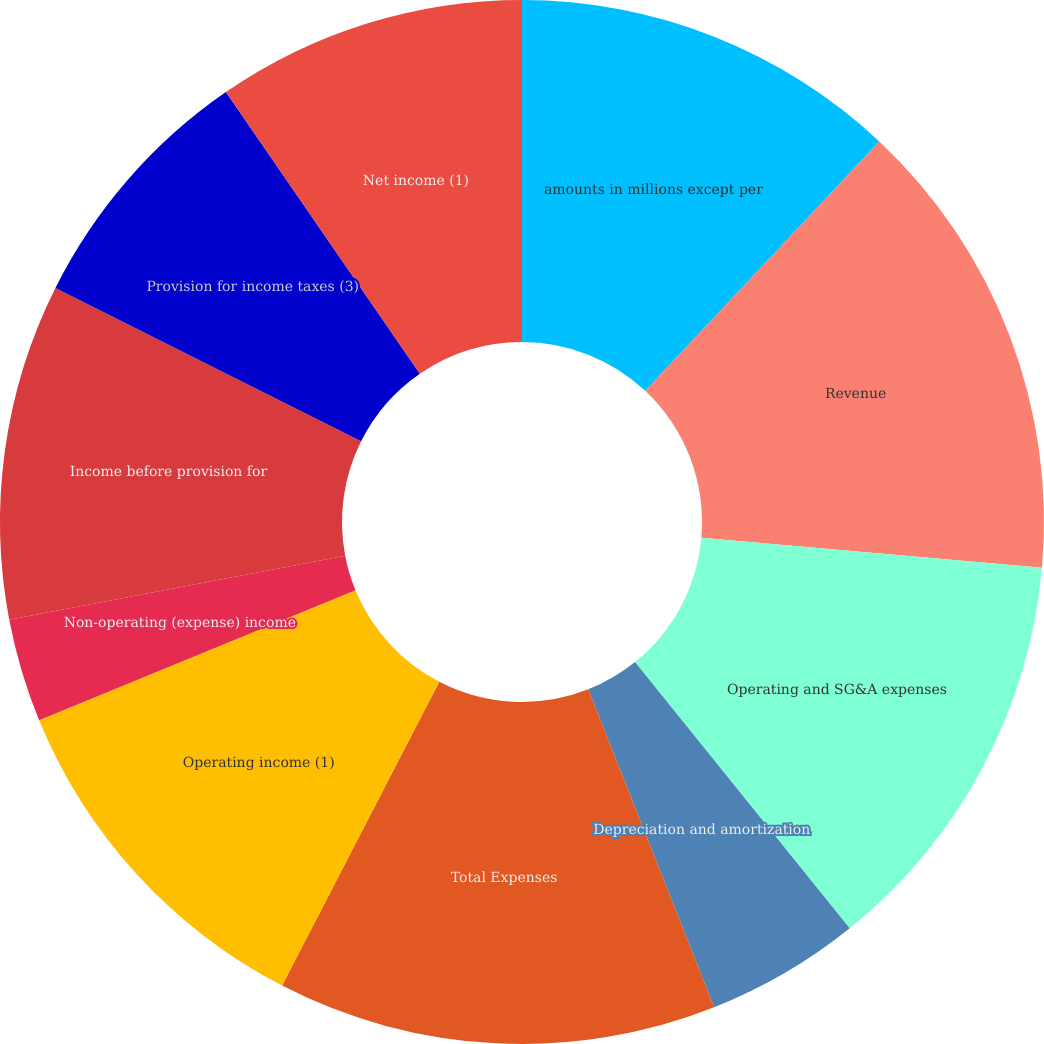<chart> <loc_0><loc_0><loc_500><loc_500><pie_chart><fcel>amounts in millions except per<fcel>Revenue<fcel>Operating and SG&A expenses<fcel>Depreciation and amortization<fcel>Total Expenses<fcel>Operating income (1)<fcel>Non-operating (expense) income<fcel>Income before provision for<fcel>Provision for income taxes (3)<fcel>Net income (1)<nl><fcel>12.0%<fcel>14.4%<fcel>12.8%<fcel>4.8%<fcel>13.6%<fcel>11.2%<fcel>3.2%<fcel>10.4%<fcel>8.0%<fcel>9.6%<nl></chart> 